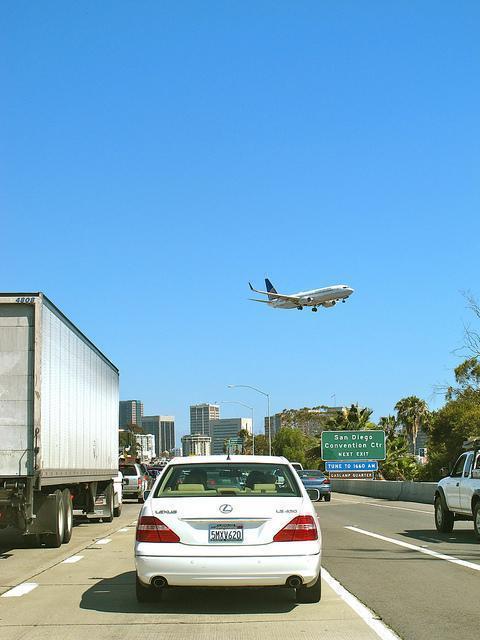This is most likely a scene from which major California city?
Indicate the correct response by choosing from the four available options to answer the question.
Options: San francisco, san diego, la, pasadena. San diego. 